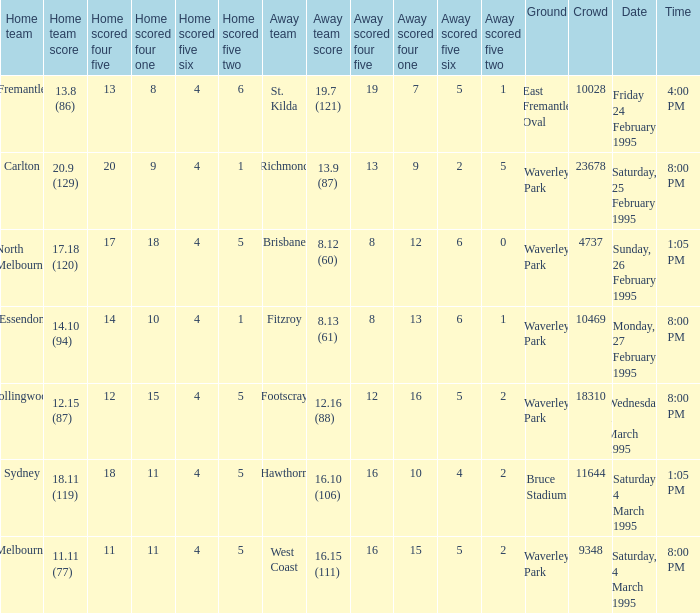Name the total number of grounds for essendon 1.0. 